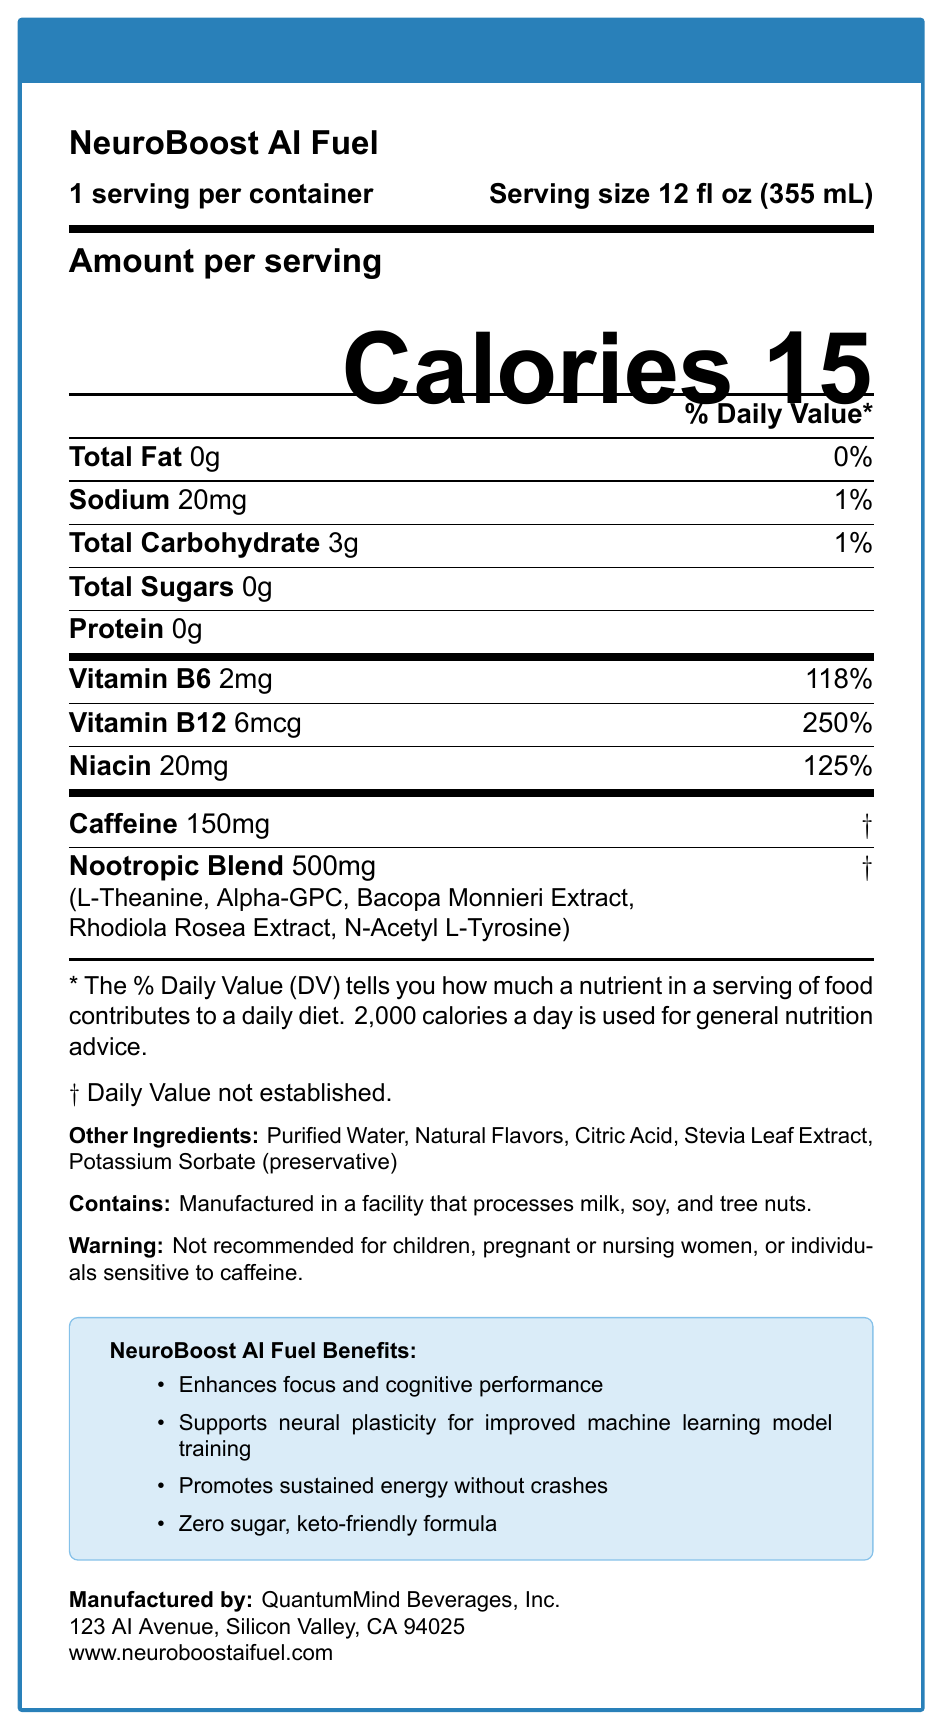what is the serving size for NeuroBoost AI Fuel? According to the document, the serving size is listed as "12 fl oz (355 mL)."
Answer: 12 fl oz (355 mL) how many calories are in one serving of NeuroBoost AI Fuel? The document specifies that there are 15 calories per serving.
Answer: 15 calories how much sodium is in one serving? The amount of sodium in one serving, according to the document, is 20 mg.
Answer: 20 mg what is the percentage daily value of niacin in a serving? The document notes that the niacin content per serving is 20 mg, which is 125% of the daily value.
Answer: 125% list the nootropic ingredients in the blend. The document provides a detailed list of the nootropic ingredients in the blend, totaling 500 mg.
Answer: L-Theanine, Alpha-GPC, Bacopa Monnieri Extract, Rhodiola Rosea Extract, N-Acetyl L-Tyrosine what are the marketing claims made about NeuroBoost AI Fuel? The document lists specific marketing claims attributed to the product.
Answer: Enhances focus and cognitive performance; Supports neural plasticity for improved machine learning model training; Promotes sustained energy without crashes; Zero sugar, keto-friendly formula how much vitamin B12 is in a serving of NeuroBoost AI Fuel? According to the document, one serving contains 6 mcg of Vitamin B12, which is 250% of the daily value.
Answer: 6 mcg (250% DV) NeuroBoost AI Fuel contains which of the following as a preservative? A. Sodium Benzoate B. Potassium Sorbate C. Calcium Propionate D. Sorbic Acid The list of other ingredients in the document specifies Potassium Sorbate as the preservative.
Answer: B. Potassium Sorbate what is NOT recommended for children, pregnant or nursing women, or individuals sensitive to caffeine? A. NeuroBoost AI Fuel B. NeuroMind Drink C. FocusFuel Beverage The document includes a warning that advises against the consumption of NeuroBoost AI Fuel for these groups.
Answer: A. NeuroBoost AI Fuel does NeuroBoost AI Fuel contain any sugar? The document explicitly states that the total sugars content per serving is 0g.
Answer: No summarize the main features and contents of the Nutrition Facts label for NeuroBoost AI Fuel. The document provides detailed nutritional information, ingredient lists, and marketing claims, emphasizing its cognitive and neural benefits, zero sugar, and its suitability for a ketogenic diet.
Answer: The Nutrition Facts label for NeuroBoost AI Fuel shows that it has a serving size of 12 fl oz (355 mL), contains 15 calories, and provides various nutritional details such as 0g total fat, 20mg sodium, 3g total carbohydrate, and 0g total sugars and protein. It contains 150mg caffeine and a 500mg nootropic blend with ingredients like L-Theanine and Alpha-GPC. Vitamins B6 and B12 are included in significant amounts. The label also lists other ingredients, allergen information, warnings, and marketing claims. how much protein does one serving of NeuroBoost AI Fuel contain? The document clearly states that the protein content per serving is 0g.
Answer: 0g what is the company address of the manufacturer, QuantumMind Beverages, Inc.? The document provides the address of the manufacturer, which is 123 AI Avenue, Silicon Valley, CA 94025.
Answer: 123 AI Avenue, Silicon Valley, CA 94025 how does NeuroBoost AI Fuel promote energy, according to its marketing claims? According to the marketing claims section, the product promotes sustained energy without crashes.
Answer: Promotes sustained energy without crashes is the daily value for Vitamin B6 listed on the packaging? The document lists the daily value for Vitamin B6, which is 118%.
Answer: Yes what is the price of NeuroBoost AI Fuel? The document does not provide any information about the price of NeuroBoost AI Fuel.
Answer: Cannot be determined 